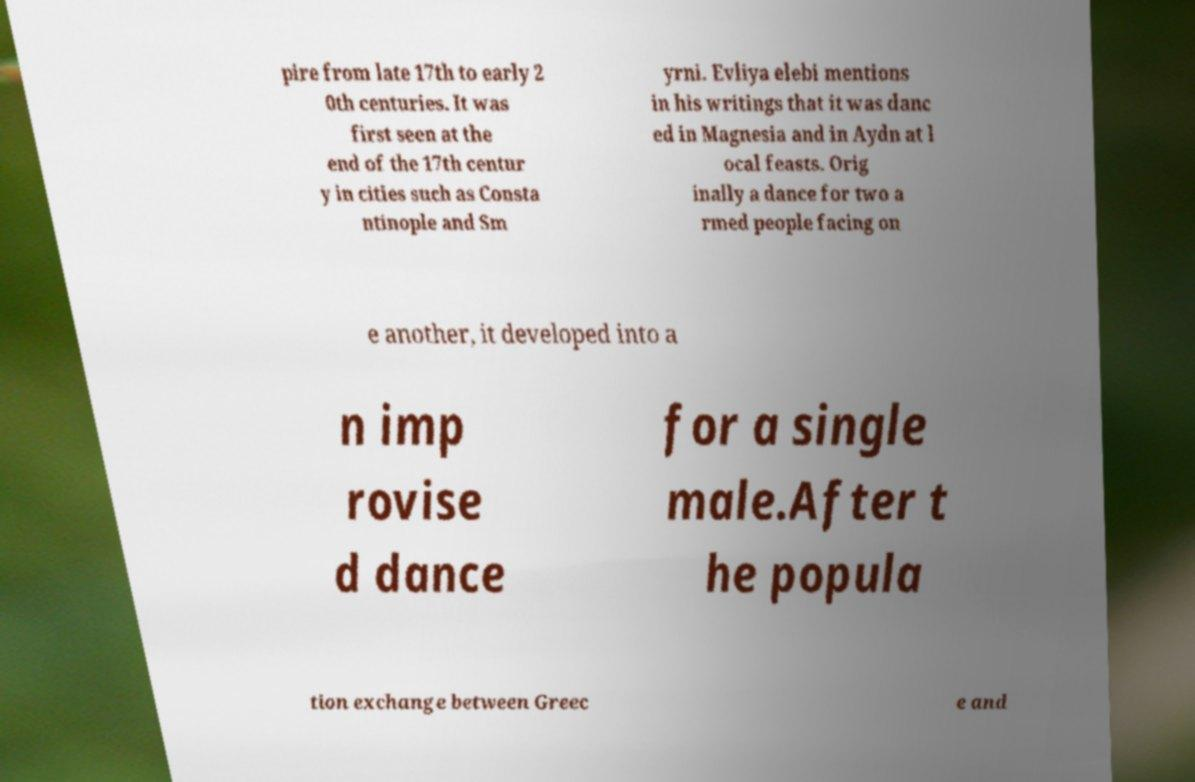Please read and relay the text visible in this image. What does it say? pire from late 17th to early 2 0th centuries. It was first seen at the end of the 17th centur y in cities such as Consta ntinople and Sm yrni. Evliya elebi mentions in his writings that it was danc ed in Magnesia and in Aydn at l ocal feasts. Orig inally a dance for two a rmed people facing on e another, it developed into a n imp rovise d dance for a single male.After t he popula tion exchange between Greec e and 